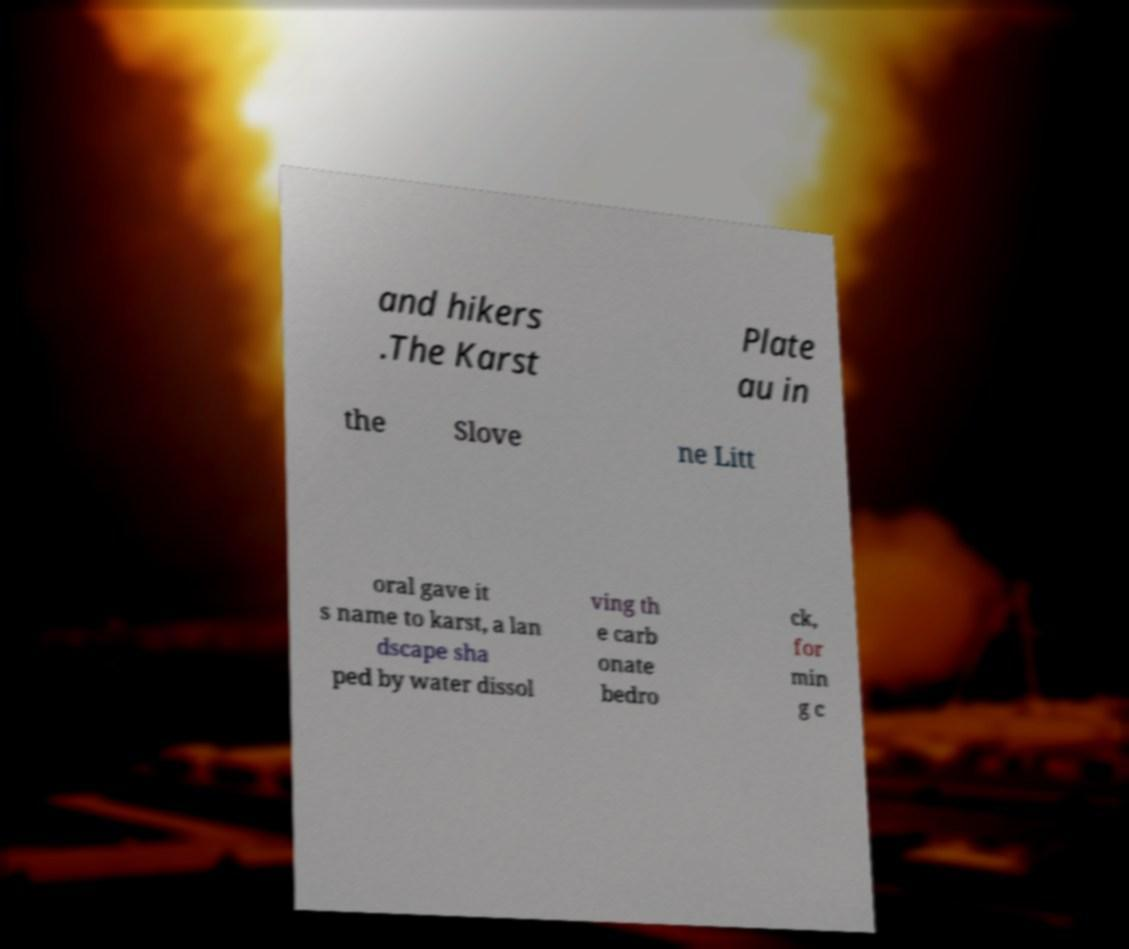Can you read and provide the text displayed in the image?This photo seems to have some interesting text. Can you extract and type it out for me? and hikers .The Karst Plate au in the Slove ne Litt oral gave it s name to karst, a lan dscape sha ped by water dissol ving th e carb onate bedro ck, for min g c 